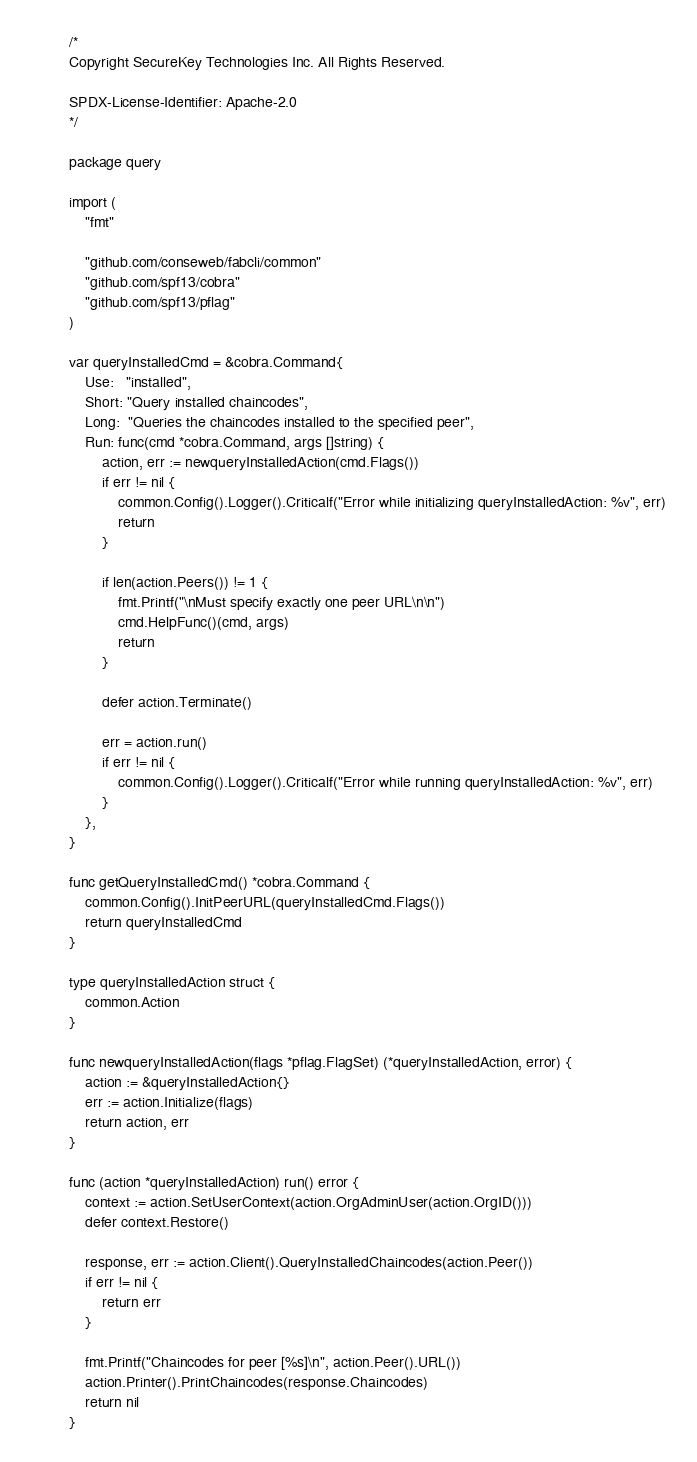<code> <loc_0><loc_0><loc_500><loc_500><_Go_>/*
Copyright SecureKey Technologies Inc. All Rights Reserved.

SPDX-License-Identifier: Apache-2.0
*/

package query

import (
	"fmt"

	"github.com/conseweb/fabcli/common"
	"github.com/spf13/cobra"
	"github.com/spf13/pflag"
)

var queryInstalledCmd = &cobra.Command{
	Use:   "installed",
	Short: "Query installed chaincodes",
	Long:  "Queries the chaincodes installed to the specified peer",
	Run: func(cmd *cobra.Command, args []string) {
		action, err := newqueryInstalledAction(cmd.Flags())
		if err != nil {
			common.Config().Logger().Criticalf("Error while initializing queryInstalledAction: %v", err)
			return
		}

		if len(action.Peers()) != 1 {
			fmt.Printf("\nMust specify exactly one peer URL\n\n")
			cmd.HelpFunc()(cmd, args)
			return
		}

		defer action.Terminate()

		err = action.run()
		if err != nil {
			common.Config().Logger().Criticalf("Error while running queryInstalledAction: %v", err)
		}
	},
}

func getQueryInstalledCmd() *cobra.Command {
	common.Config().InitPeerURL(queryInstalledCmd.Flags())
	return queryInstalledCmd
}

type queryInstalledAction struct {
	common.Action
}

func newqueryInstalledAction(flags *pflag.FlagSet) (*queryInstalledAction, error) {
	action := &queryInstalledAction{}
	err := action.Initialize(flags)
	return action, err
}

func (action *queryInstalledAction) run() error {
	context := action.SetUserContext(action.OrgAdminUser(action.OrgID()))
	defer context.Restore()

	response, err := action.Client().QueryInstalledChaincodes(action.Peer())
	if err != nil {
		return err
	}

	fmt.Printf("Chaincodes for peer [%s]\n", action.Peer().URL())
	action.Printer().PrintChaincodes(response.Chaincodes)
	return nil
}
</code> 